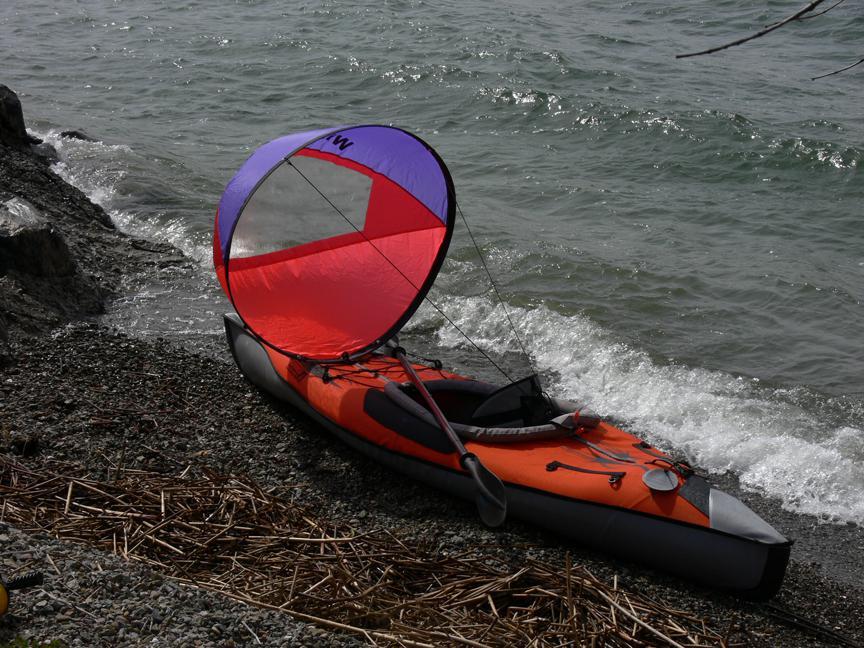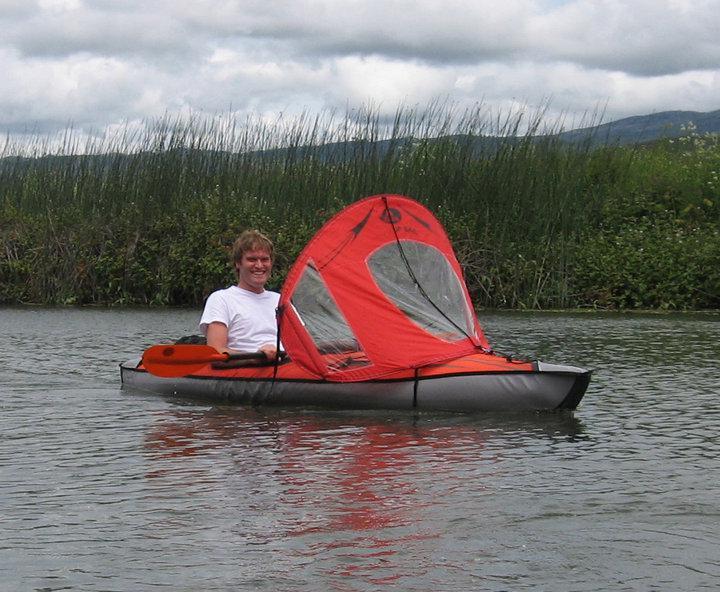The first image is the image on the left, the second image is the image on the right. Given the left and right images, does the statement "There is a person in a canoe, on the water, facing right." hold true? Answer yes or no. Yes. The first image is the image on the left, the second image is the image on the right. Given the left and right images, does the statement "There is a red canoe in water in the left image." hold true? Answer yes or no. No. 